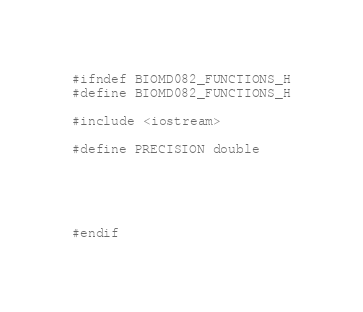Convert code to text. <code><loc_0><loc_0><loc_500><loc_500><_Cuda_>
#ifndef BIOMD082_FUNCTIONS_H
#define BIOMD082_FUNCTIONS_H

#include <iostream>

#define PRECISION double





#endif
</code> 